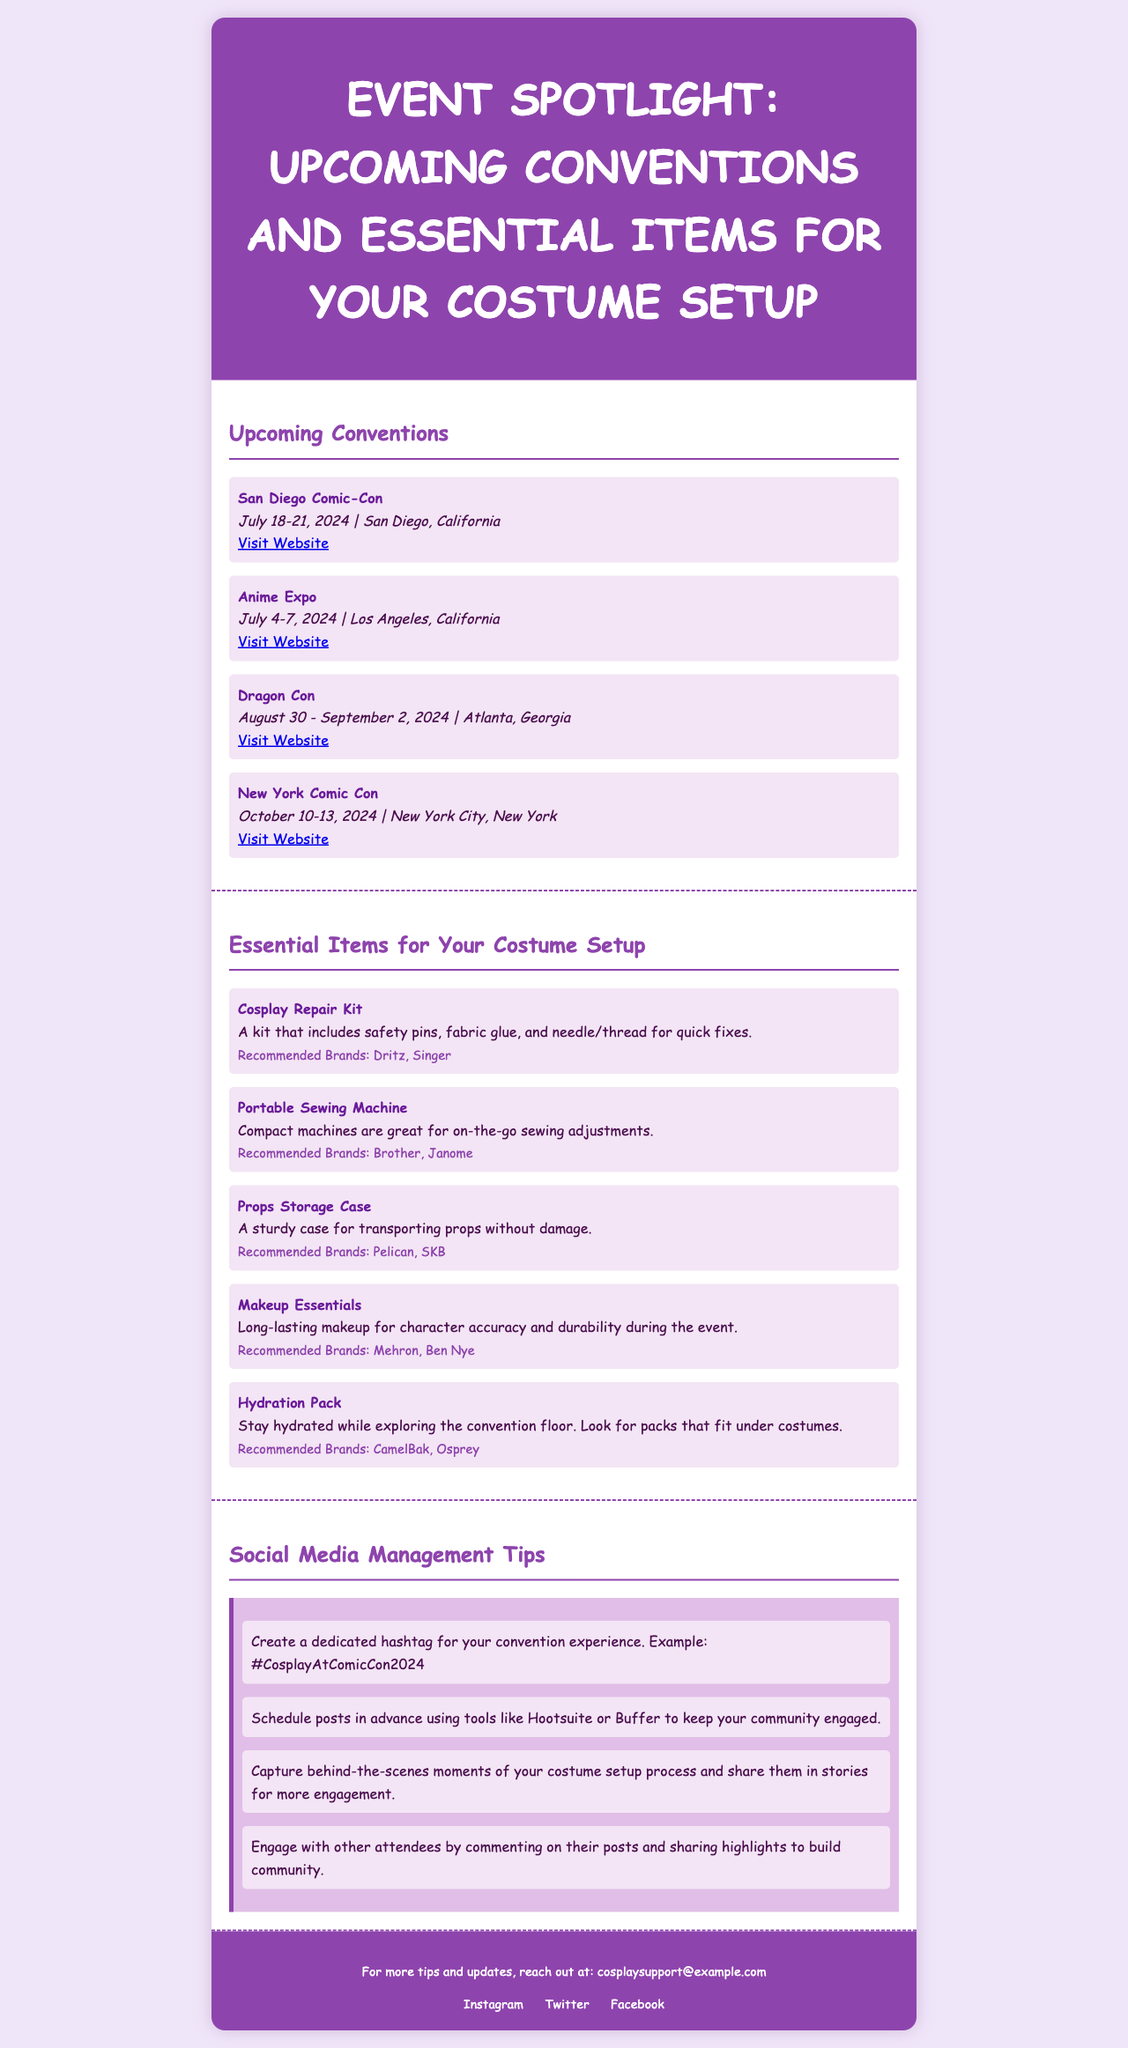What are the dates for Anime Expo? The document lists the event details for Anime Expo, specifically mentioning it occurs from July 4-7, 2024.
Answer: July 4-7, 2024 What is the location of Dragon Con? The event details for Dragon Con indicate that it takes place in Atlanta, Georgia.
Answer: Atlanta, Georgia Which brand is recommended for makeup essentials? The document identifies Mehron and Ben Nye as the recommended brands for makeup essentials.
Answer: Mehron, Ben Nye What type of item is a "Cosplay Repair Kit"? The document describes a Cosplay Repair Kit as an essential item for quick fixes during costume setup.
Answer: Essential item for quick fixes How many conventions are listed in the newsletter? By counting the entries in the Upcoming Conventions section, there are four listed conventions.
Answer: Four What should you create to engage with your community? The social media tips recommend creating a dedicated hashtag for your convention experience.
Answer: Dedicated hashtag Which brand is suggested for hydration packs? The document recommends CamelBak and Osprey as brands for hydration packs.
Answer: CamelBak, Osprey What should you schedule in advance according to the social media tips? The document suggests scheduling posts in advance to keep your community engaged.
Answer: Posts in advance What is the title of the newsletter? The newsletter's title, mentioned in the header, is "Event Spotlight: Upcoming Conventions and Essential Items for Your Costume Setup."
Answer: Event Spotlight: Upcoming Conventions and Essential Items for Your Costume Setup 